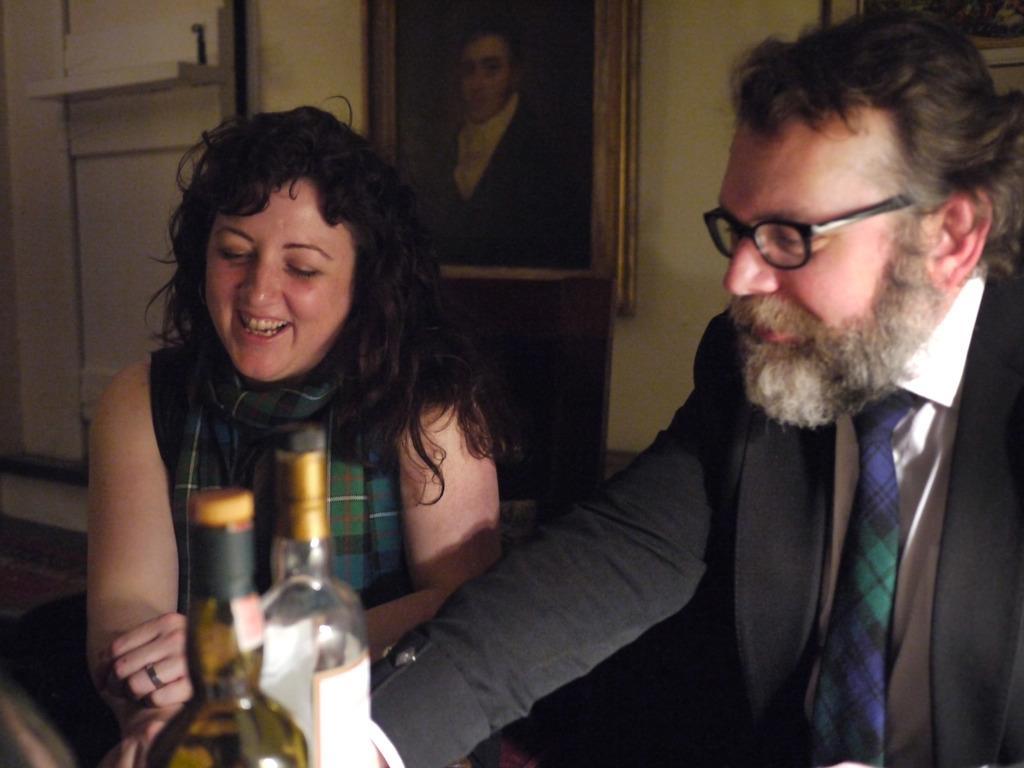Can you describe this image briefly? As we can see in the image there is a wall, photo frame, two people sitting on chairs and two bottles. 